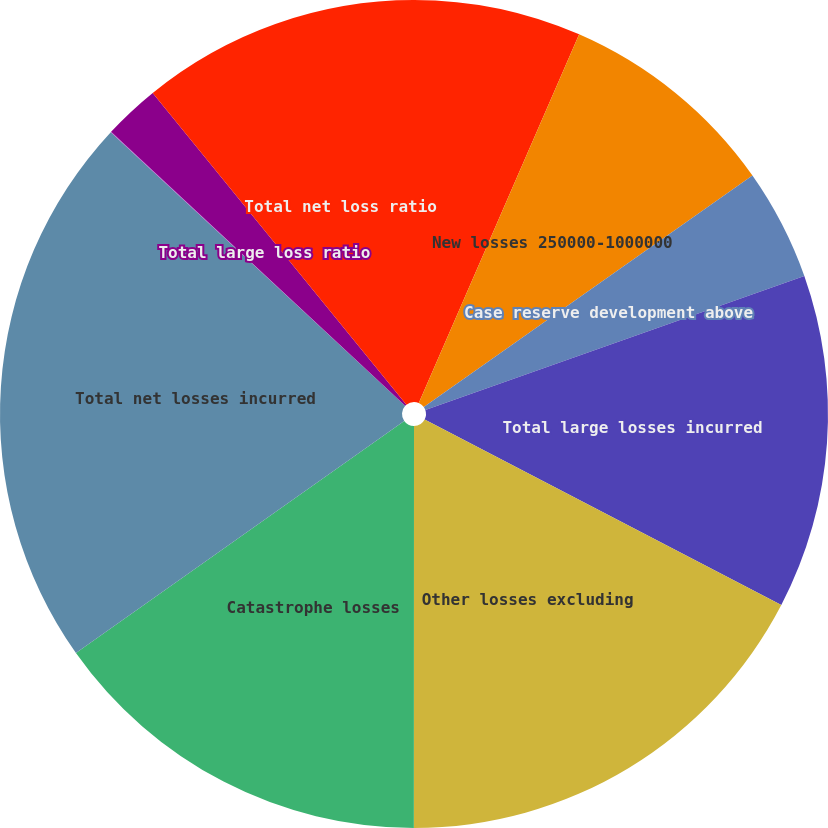Convert chart. <chart><loc_0><loc_0><loc_500><loc_500><pie_chart><fcel>New losses 1000000-4000000<fcel>New losses 250000-1000000<fcel>Case reserve development above<fcel>Total large losses incurred<fcel>Other losses excluding<fcel>Catastrophe losses<fcel>Total net losses incurred<fcel>New losses greater than<fcel>Total large loss ratio<fcel>Total net loss ratio<nl><fcel>6.53%<fcel>8.7%<fcel>4.36%<fcel>13.04%<fcel>17.37%<fcel>15.2%<fcel>21.71%<fcel>0.02%<fcel>2.19%<fcel>10.87%<nl></chart> 